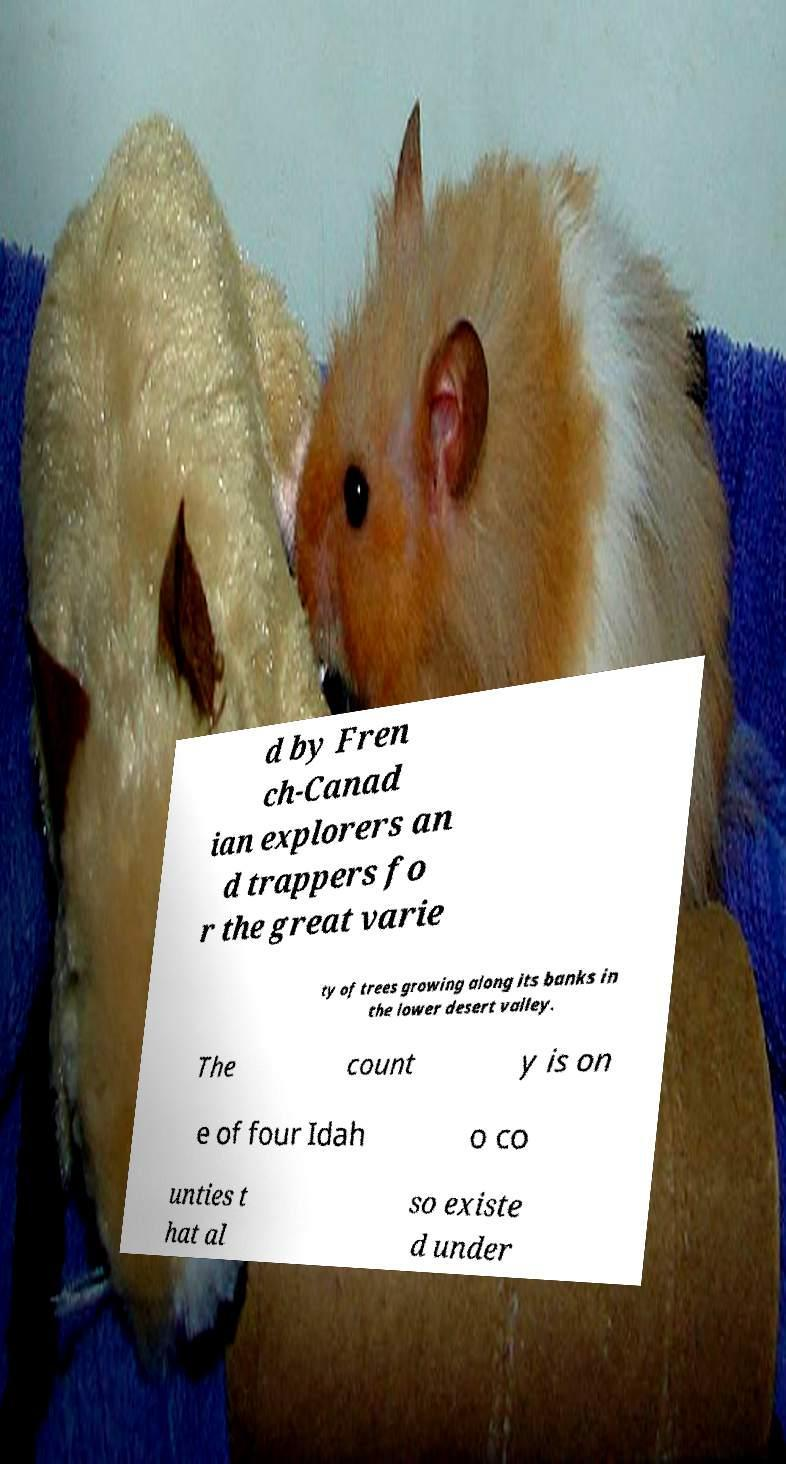Can you read and provide the text displayed in the image?This photo seems to have some interesting text. Can you extract and type it out for me? d by Fren ch-Canad ian explorers an d trappers fo r the great varie ty of trees growing along its banks in the lower desert valley. The count y is on e of four Idah o co unties t hat al so existe d under 